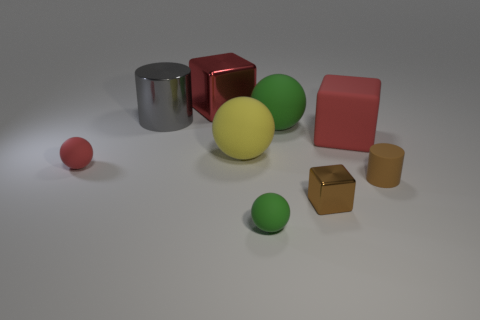Subtract 1 spheres. How many spheres are left? 3 Add 1 big gray shiny cylinders. How many objects exist? 10 Subtract all cylinders. How many objects are left? 7 Subtract 0 blue balls. How many objects are left? 9 Subtract all green things. Subtract all large yellow matte things. How many objects are left? 6 Add 2 big metallic blocks. How many big metallic blocks are left? 3 Add 8 tiny metal blocks. How many tiny metal blocks exist? 9 